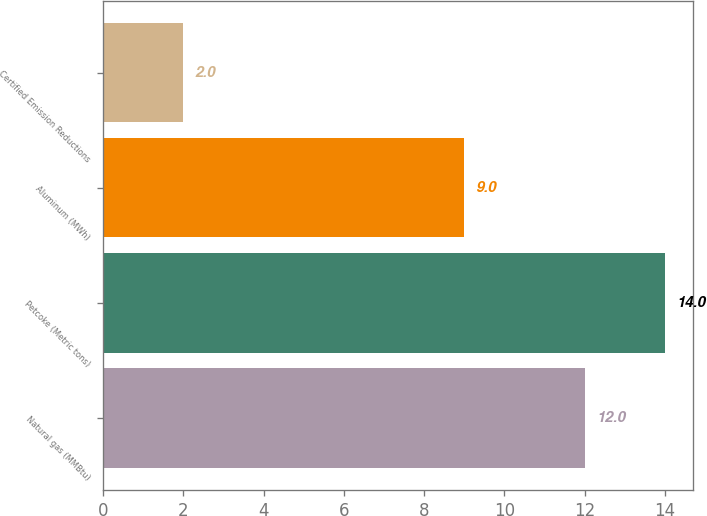Convert chart to OTSL. <chart><loc_0><loc_0><loc_500><loc_500><bar_chart><fcel>Natural gas (MMBtu)<fcel>Petcoke (Metric tons)<fcel>Aluminum (MWh)<fcel>Certified Emission Reductions<nl><fcel>12<fcel>14<fcel>9<fcel>2<nl></chart> 